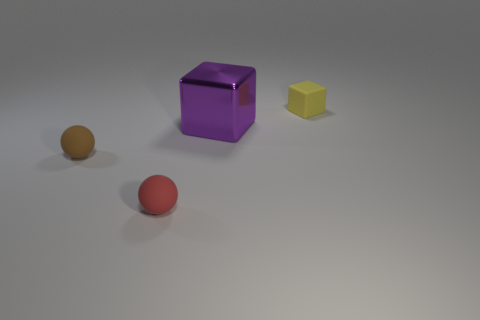Add 3 tiny gray objects. How many objects exist? 7 Subtract 0 brown cubes. How many objects are left? 4 Subtract all large brown rubber cubes. Subtract all big purple objects. How many objects are left? 3 Add 1 yellow things. How many yellow things are left? 2 Add 4 big green matte balls. How many big green matte balls exist? 4 